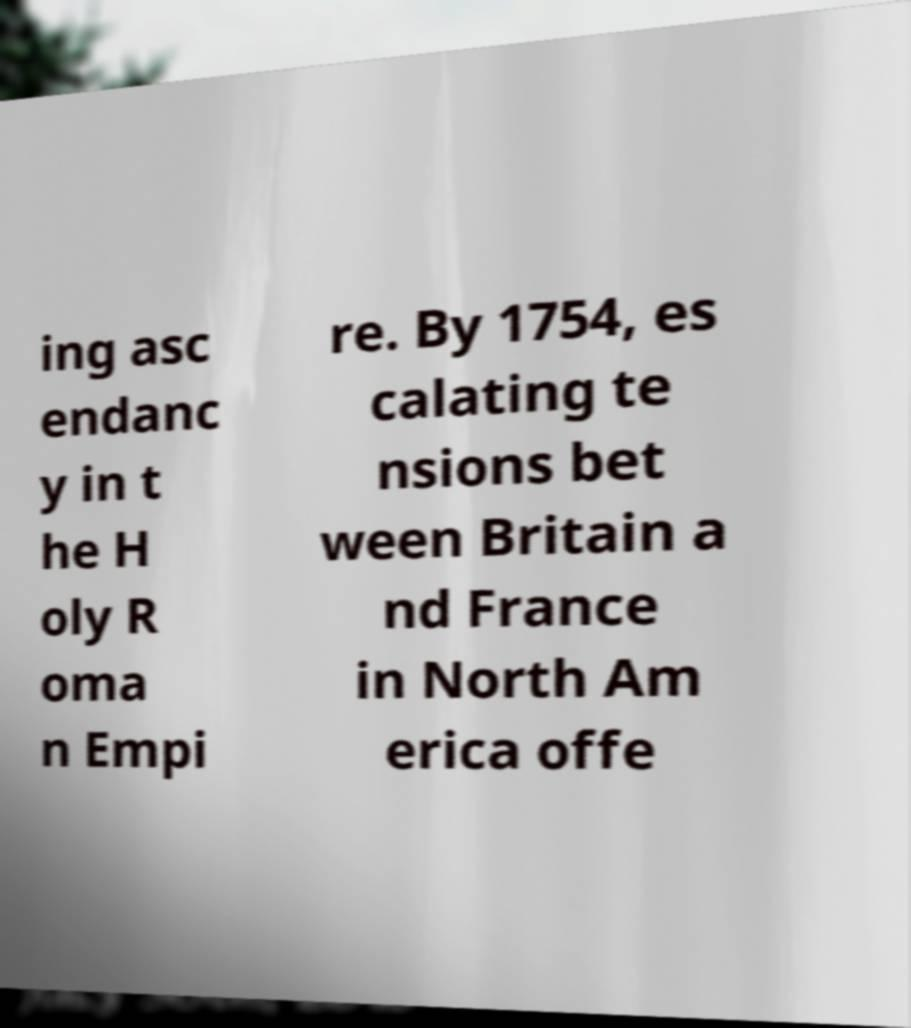Please read and relay the text visible in this image. What does it say? ing asc endanc y in t he H oly R oma n Empi re. By 1754, es calating te nsions bet ween Britain a nd France in North Am erica offe 